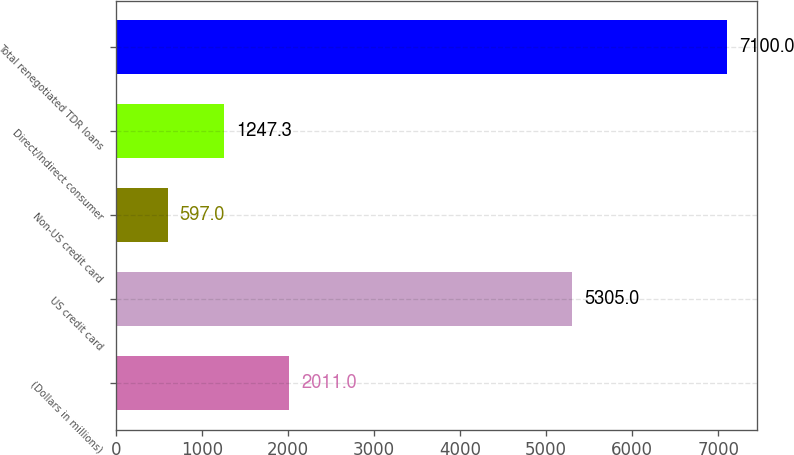Convert chart to OTSL. <chart><loc_0><loc_0><loc_500><loc_500><bar_chart><fcel>(Dollars in millions)<fcel>US credit card<fcel>Non-US credit card<fcel>Direct/Indirect consumer<fcel>Total renegotiated TDR loans<nl><fcel>2011<fcel>5305<fcel>597<fcel>1247.3<fcel>7100<nl></chart> 